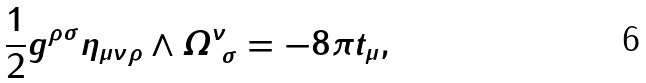<formula> <loc_0><loc_0><loc_500><loc_500>\frac { 1 } { 2 } g ^ { \rho \sigma } \eta _ { \mu \nu \rho } \wedge \varOmega ^ { \nu } _ { \ \sigma } = - 8 \pi t _ { \mu } ,</formula> 